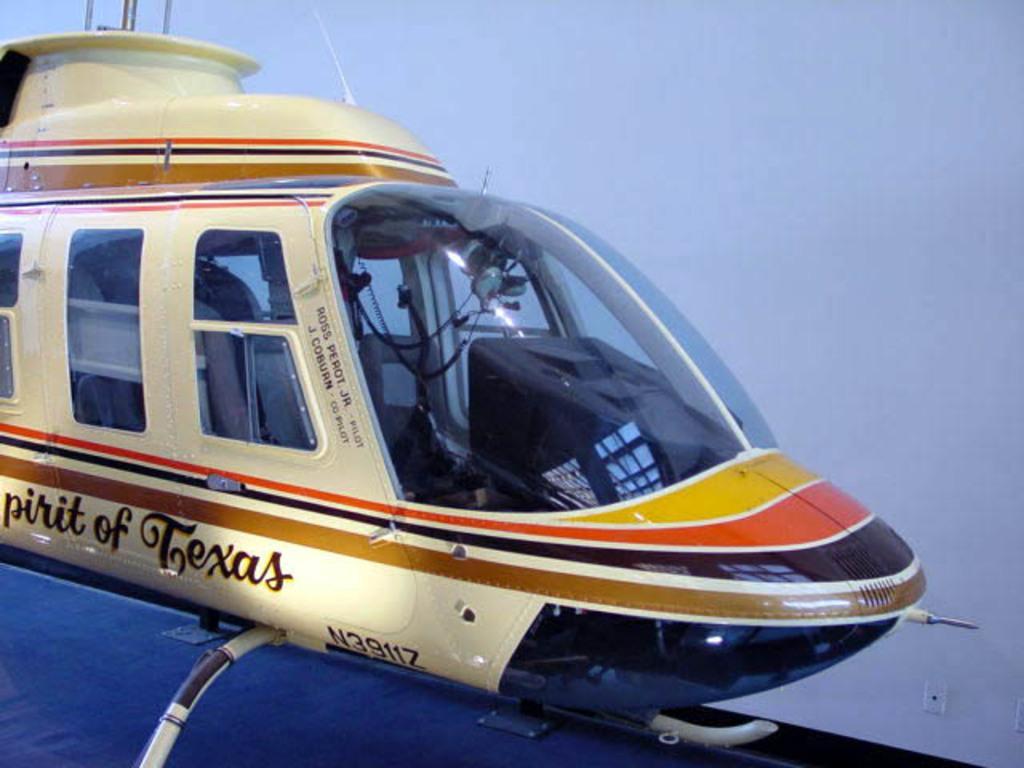Could you give a brief overview of what you see in this image? Here we can see an airplane which is truncated and there is a white background. 